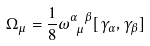Convert formula to latex. <formula><loc_0><loc_0><loc_500><loc_500>\Omega _ { \mu } = \frac { 1 } { 8 } \omega ^ { \alpha \ \beta } _ { \ \mu } [ \gamma _ { \alpha } , \gamma _ { \beta } ]</formula> 